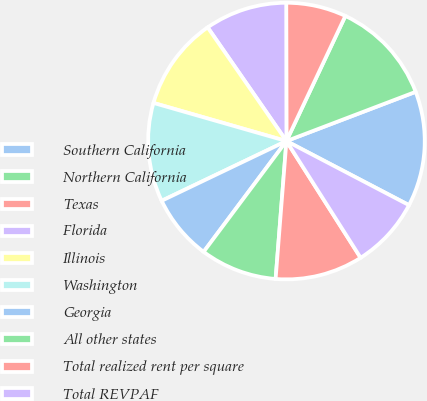Convert chart to OTSL. <chart><loc_0><loc_0><loc_500><loc_500><pie_chart><fcel>Southern California<fcel>Northern California<fcel>Texas<fcel>Florida<fcel>Illinois<fcel>Washington<fcel>Georgia<fcel>All other states<fcel>Total realized rent per square<fcel>Total REVPAF<nl><fcel>13.46%<fcel>12.2%<fcel>7.03%<fcel>9.62%<fcel>10.91%<fcel>11.55%<fcel>7.68%<fcel>8.97%<fcel>10.26%<fcel>8.32%<nl></chart> 